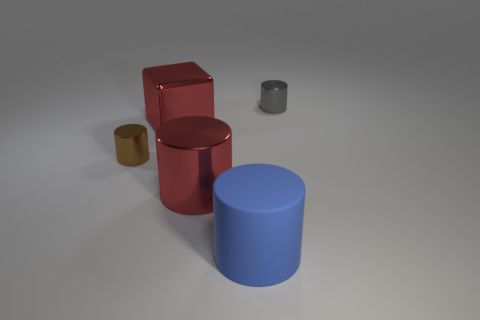What is the shape of the large metal thing that is the same color as the big metal cylinder?
Your answer should be compact. Cube. What number of big rubber cylinders have the same color as the large block?
Provide a succinct answer. 0. There is a red thing that is behind the brown shiny object; is it the same shape as the shiny object right of the blue object?
Provide a succinct answer. No. There is a large metal thing to the right of the large red shiny object that is behind the tiny shiny object left of the red shiny cylinder; what color is it?
Your response must be concise. Red. What is the color of the small thing in front of the small gray metallic cylinder?
Your response must be concise. Brown. The shiny cylinder that is the same size as the brown shiny thing is what color?
Provide a succinct answer. Gray. Do the red block and the blue rubber object have the same size?
Make the answer very short. Yes. How many big metal objects are in front of the red metallic block?
Your answer should be compact. 1. What number of things are metallic cylinders that are behind the big red cylinder or small red spheres?
Your answer should be compact. 2. Are there more big things that are to the left of the red block than gray shiny things that are on the left side of the blue cylinder?
Your answer should be very brief. No. 